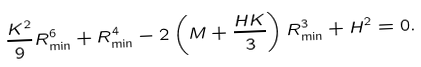Convert formula to latex. <formula><loc_0><loc_0><loc_500><loc_500>\frac { K ^ { 2 } } { 9 } R _ { \min } ^ { 6 } + R _ { \min } ^ { 4 } - 2 \left ( M + \frac { H K } { 3 } \right ) R _ { \min } ^ { 3 } + H ^ { 2 } = 0 .</formula> 